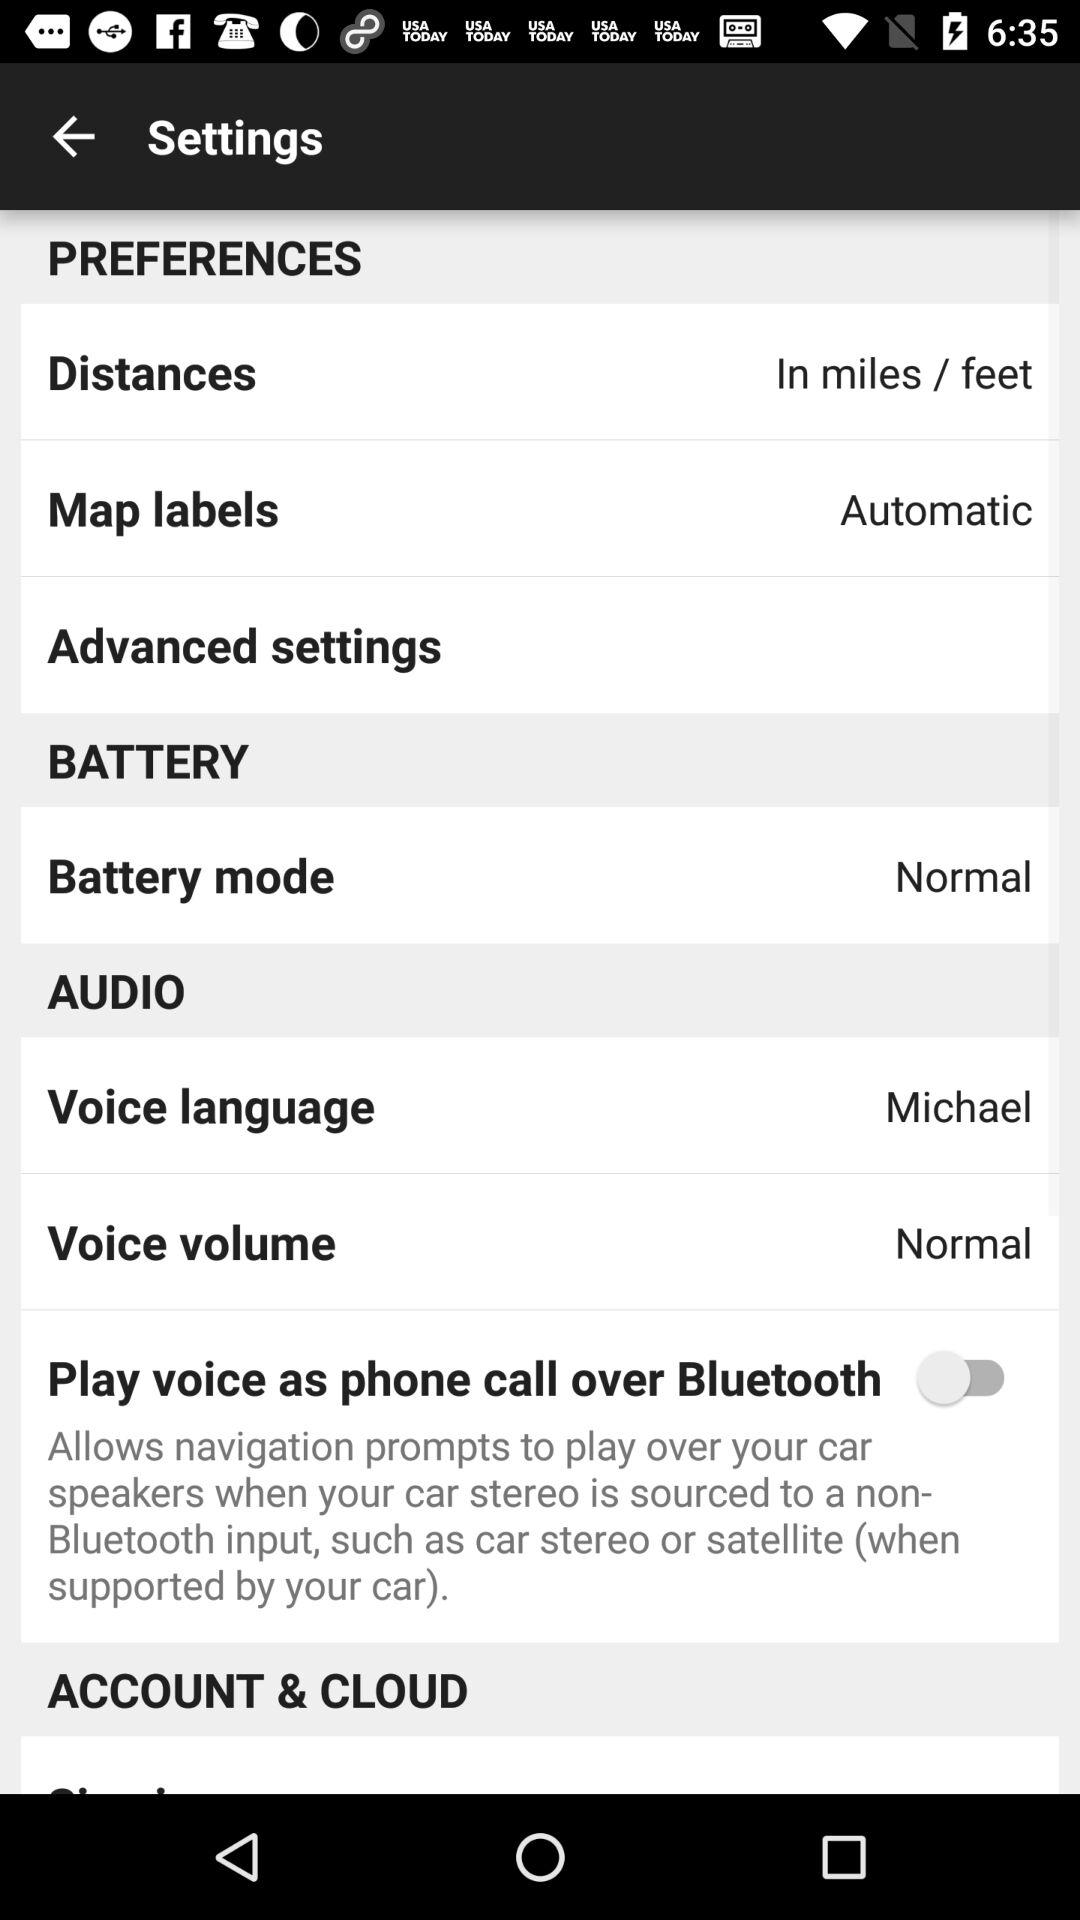What are the measurement unit options for the distance? The measurement unit options are miles and feet. 